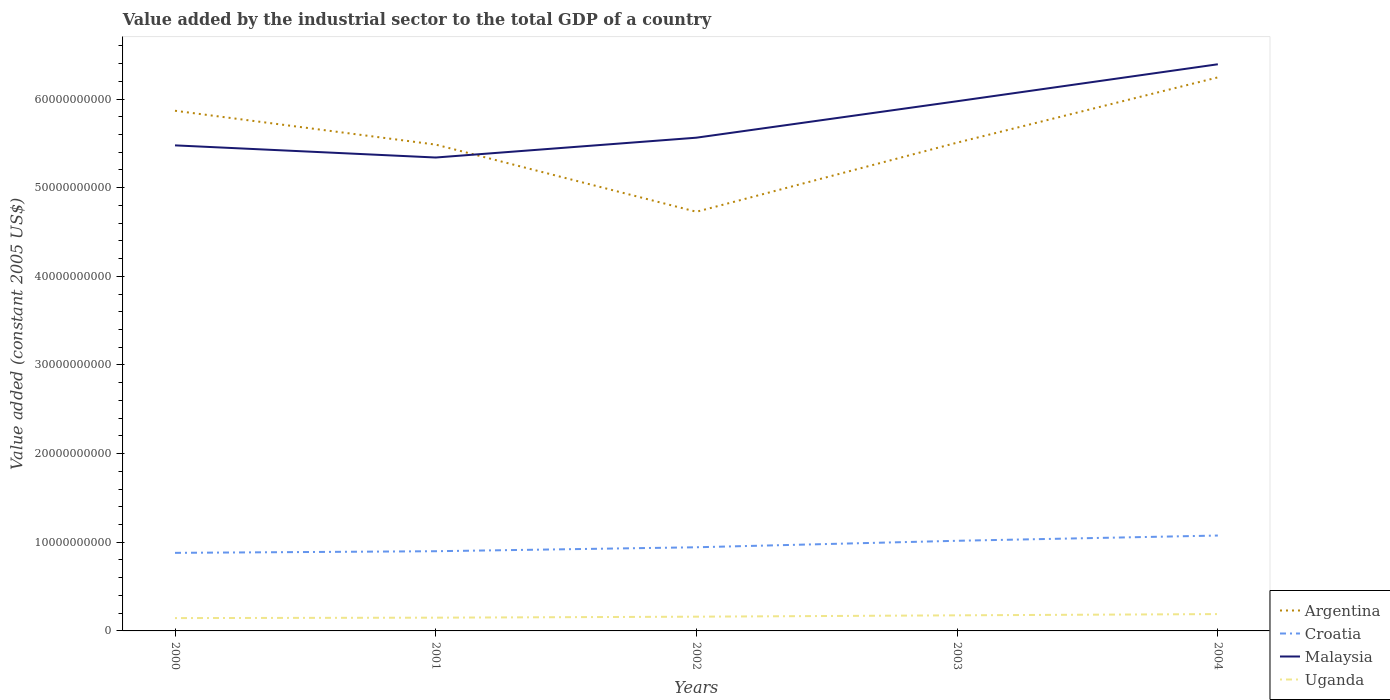Does the line corresponding to Croatia intersect with the line corresponding to Argentina?
Give a very brief answer. No. Is the number of lines equal to the number of legend labels?
Your response must be concise. Yes. Across all years, what is the maximum value added by the industrial sector in Croatia?
Provide a succinct answer. 8.81e+09. In which year was the value added by the industrial sector in Argentina maximum?
Provide a short and direct response. 2002. What is the total value added by the industrial sector in Uganda in the graph?
Offer a very short reply. -1.58e+08. What is the difference between the highest and the second highest value added by the industrial sector in Argentina?
Give a very brief answer. 1.52e+1. What is the difference between two consecutive major ticks on the Y-axis?
Your answer should be compact. 1.00e+1. Are the values on the major ticks of Y-axis written in scientific E-notation?
Your response must be concise. No. Does the graph contain any zero values?
Offer a terse response. No. Does the graph contain grids?
Give a very brief answer. No. Where does the legend appear in the graph?
Make the answer very short. Bottom right. How many legend labels are there?
Offer a very short reply. 4. What is the title of the graph?
Provide a succinct answer. Value added by the industrial sector to the total GDP of a country. Does "Dominican Republic" appear as one of the legend labels in the graph?
Your answer should be very brief. No. What is the label or title of the Y-axis?
Give a very brief answer. Value added (constant 2005 US$). What is the Value added (constant 2005 US$) in Argentina in 2000?
Make the answer very short. 5.87e+1. What is the Value added (constant 2005 US$) in Croatia in 2000?
Give a very brief answer. 8.81e+09. What is the Value added (constant 2005 US$) of Malaysia in 2000?
Your answer should be very brief. 5.48e+1. What is the Value added (constant 2005 US$) of Uganda in 2000?
Your answer should be compact. 1.45e+09. What is the Value added (constant 2005 US$) in Argentina in 2001?
Offer a terse response. 5.49e+1. What is the Value added (constant 2005 US$) of Croatia in 2001?
Provide a short and direct response. 8.99e+09. What is the Value added (constant 2005 US$) of Malaysia in 2001?
Ensure brevity in your answer.  5.34e+1. What is the Value added (constant 2005 US$) of Uganda in 2001?
Keep it short and to the point. 1.50e+09. What is the Value added (constant 2005 US$) in Argentina in 2002?
Your answer should be very brief. 4.73e+1. What is the Value added (constant 2005 US$) in Croatia in 2002?
Give a very brief answer. 9.44e+09. What is the Value added (constant 2005 US$) in Malaysia in 2002?
Offer a very short reply. 5.56e+1. What is the Value added (constant 2005 US$) in Uganda in 2002?
Make the answer very short. 1.61e+09. What is the Value added (constant 2005 US$) of Argentina in 2003?
Give a very brief answer. 5.51e+1. What is the Value added (constant 2005 US$) of Croatia in 2003?
Your answer should be very brief. 1.02e+1. What is the Value added (constant 2005 US$) of Malaysia in 2003?
Offer a terse response. 5.97e+1. What is the Value added (constant 2005 US$) of Uganda in 2003?
Your answer should be very brief. 1.76e+09. What is the Value added (constant 2005 US$) in Argentina in 2004?
Offer a terse response. 6.24e+1. What is the Value added (constant 2005 US$) in Croatia in 2004?
Your answer should be very brief. 1.08e+1. What is the Value added (constant 2005 US$) of Malaysia in 2004?
Offer a terse response. 6.39e+1. What is the Value added (constant 2005 US$) of Uganda in 2004?
Provide a succinct answer. 1.90e+09. Across all years, what is the maximum Value added (constant 2005 US$) of Argentina?
Your answer should be very brief. 6.24e+1. Across all years, what is the maximum Value added (constant 2005 US$) of Croatia?
Keep it short and to the point. 1.08e+1. Across all years, what is the maximum Value added (constant 2005 US$) of Malaysia?
Make the answer very short. 6.39e+1. Across all years, what is the maximum Value added (constant 2005 US$) of Uganda?
Keep it short and to the point. 1.90e+09. Across all years, what is the minimum Value added (constant 2005 US$) in Argentina?
Give a very brief answer. 4.73e+1. Across all years, what is the minimum Value added (constant 2005 US$) in Croatia?
Give a very brief answer. 8.81e+09. Across all years, what is the minimum Value added (constant 2005 US$) of Malaysia?
Your answer should be compact. 5.34e+1. Across all years, what is the minimum Value added (constant 2005 US$) in Uganda?
Ensure brevity in your answer.  1.45e+09. What is the total Value added (constant 2005 US$) of Argentina in the graph?
Give a very brief answer. 2.78e+11. What is the total Value added (constant 2005 US$) in Croatia in the graph?
Your response must be concise. 4.82e+1. What is the total Value added (constant 2005 US$) in Malaysia in the graph?
Provide a short and direct response. 2.87e+11. What is the total Value added (constant 2005 US$) in Uganda in the graph?
Keep it short and to the point. 8.21e+09. What is the difference between the Value added (constant 2005 US$) of Argentina in 2000 and that in 2001?
Make the answer very short. 3.82e+09. What is the difference between the Value added (constant 2005 US$) of Croatia in 2000 and that in 2001?
Offer a very short reply. -1.84e+08. What is the difference between the Value added (constant 2005 US$) of Malaysia in 2000 and that in 2001?
Offer a terse response. 1.37e+09. What is the difference between the Value added (constant 2005 US$) in Uganda in 2000 and that in 2001?
Keep it short and to the point. -4.72e+07. What is the difference between the Value added (constant 2005 US$) of Argentina in 2000 and that in 2002?
Provide a succinct answer. 1.14e+1. What is the difference between the Value added (constant 2005 US$) of Croatia in 2000 and that in 2002?
Your answer should be compact. -6.30e+08. What is the difference between the Value added (constant 2005 US$) in Malaysia in 2000 and that in 2002?
Offer a terse response. -8.67e+08. What is the difference between the Value added (constant 2005 US$) in Uganda in 2000 and that in 2002?
Offer a terse response. -1.58e+08. What is the difference between the Value added (constant 2005 US$) in Argentina in 2000 and that in 2003?
Offer a very short reply. 3.60e+09. What is the difference between the Value added (constant 2005 US$) in Croatia in 2000 and that in 2003?
Your answer should be very brief. -1.36e+09. What is the difference between the Value added (constant 2005 US$) of Malaysia in 2000 and that in 2003?
Your answer should be compact. -4.98e+09. What is the difference between the Value added (constant 2005 US$) in Uganda in 2000 and that in 2003?
Ensure brevity in your answer.  -3.10e+08. What is the difference between the Value added (constant 2005 US$) in Argentina in 2000 and that in 2004?
Your answer should be compact. -3.77e+09. What is the difference between the Value added (constant 2005 US$) in Croatia in 2000 and that in 2004?
Provide a succinct answer. -1.95e+09. What is the difference between the Value added (constant 2005 US$) in Malaysia in 2000 and that in 2004?
Offer a very short reply. -9.15e+09. What is the difference between the Value added (constant 2005 US$) of Uganda in 2000 and that in 2004?
Your response must be concise. -4.51e+08. What is the difference between the Value added (constant 2005 US$) in Argentina in 2001 and that in 2002?
Your response must be concise. 7.58e+09. What is the difference between the Value added (constant 2005 US$) of Croatia in 2001 and that in 2002?
Provide a succinct answer. -4.45e+08. What is the difference between the Value added (constant 2005 US$) in Malaysia in 2001 and that in 2002?
Your response must be concise. -2.24e+09. What is the difference between the Value added (constant 2005 US$) in Uganda in 2001 and that in 2002?
Keep it short and to the point. -1.11e+08. What is the difference between the Value added (constant 2005 US$) in Argentina in 2001 and that in 2003?
Provide a succinct answer. -2.20e+08. What is the difference between the Value added (constant 2005 US$) of Croatia in 2001 and that in 2003?
Keep it short and to the point. -1.18e+09. What is the difference between the Value added (constant 2005 US$) in Malaysia in 2001 and that in 2003?
Your answer should be compact. -6.35e+09. What is the difference between the Value added (constant 2005 US$) in Uganda in 2001 and that in 2003?
Provide a succinct answer. -2.63e+08. What is the difference between the Value added (constant 2005 US$) of Argentina in 2001 and that in 2004?
Your response must be concise. -7.58e+09. What is the difference between the Value added (constant 2005 US$) of Croatia in 2001 and that in 2004?
Your answer should be compact. -1.77e+09. What is the difference between the Value added (constant 2005 US$) of Malaysia in 2001 and that in 2004?
Keep it short and to the point. -1.05e+1. What is the difference between the Value added (constant 2005 US$) of Uganda in 2001 and that in 2004?
Your response must be concise. -4.04e+08. What is the difference between the Value added (constant 2005 US$) in Argentina in 2002 and that in 2003?
Your answer should be very brief. -7.80e+09. What is the difference between the Value added (constant 2005 US$) of Croatia in 2002 and that in 2003?
Your response must be concise. -7.32e+08. What is the difference between the Value added (constant 2005 US$) in Malaysia in 2002 and that in 2003?
Make the answer very short. -4.11e+09. What is the difference between the Value added (constant 2005 US$) in Uganda in 2002 and that in 2003?
Offer a terse response. -1.52e+08. What is the difference between the Value added (constant 2005 US$) in Argentina in 2002 and that in 2004?
Ensure brevity in your answer.  -1.52e+1. What is the difference between the Value added (constant 2005 US$) of Croatia in 2002 and that in 2004?
Offer a very short reply. -1.32e+09. What is the difference between the Value added (constant 2005 US$) of Malaysia in 2002 and that in 2004?
Make the answer very short. -8.28e+09. What is the difference between the Value added (constant 2005 US$) of Uganda in 2002 and that in 2004?
Your answer should be compact. -2.93e+08. What is the difference between the Value added (constant 2005 US$) of Argentina in 2003 and that in 2004?
Your answer should be compact. -7.36e+09. What is the difference between the Value added (constant 2005 US$) in Croatia in 2003 and that in 2004?
Your response must be concise. -5.92e+08. What is the difference between the Value added (constant 2005 US$) of Malaysia in 2003 and that in 2004?
Offer a very short reply. -4.17e+09. What is the difference between the Value added (constant 2005 US$) in Uganda in 2003 and that in 2004?
Offer a very short reply. -1.41e+08. What is the difference between the Value added (constant 2005 US$) in Argentina in 2000 and the Value added (constant 2005 US$) in Croatia in 2001?
Make the answer very short. 4.97e+1. What is the difference between the Value added (constant 2005 US$) in Argentina in 2000 and the Value added (constant 2005 US$) in Malaysia in 2001?
Offer a very short reply. 5.27e+09. What is the difference between the Value added (constant 2005 US$) in Argentina in 2000 and the Value added (constant 2005 US$) in Uganda in 2001?
Your response must be concise. 5.72e+1. What is the difference between the Value added (constant 2005 US$) in Croatia in 2000 and the Value added (constant 2005 US$) in Malaysia in 2001?
Your answer should be compact. -4.46e+1. What is the difference between the Value added (constant 2005 US$) of Croatia in 2000 and the Value added (constant 2005 US$) of Uganda in 2001?
Your response must be concise. 7.31e+09. What is the difference between the Value added (constant 2005 US$) of Malaysia in 2000 and the Value added (constant 2005 US$) of Uganda in 2001?
Make the answer very short. 5.33e+1. What is the difference between the Value added (constant 2005 US$) of Argentina in 2000 and the Value added (constant 2005 US$) of Croatia in 2002?
Ensure brevity in your answer.  4.92e+1. What is the difference between the Value added (constant 2005 US$) in Argentina in 2000 and the Value added (constant 2005 US$) in Malaysia in 2002?
Your answer should be very brief. 3.04e+09. What is the difference between the Value added (constant 2005 US$) in Argentina in 2000 and the Value added (constant 2005 US$) in Uganda in 2002?
Offer a very short reply. 5.71e+1. What is the difference between the Value added (constant 2005 US$) of Croatia in 2000 and the Value added (constant 2005 US$) of Malaysia in 2002?
Give a very brief answer. -4.68e+1. What is the difference between the Value added (constant 2005 US$) of Croatia in 2000 and the Value added (constant 2005 US$) of Uganda in 2002?
Your answer should be very brief. 7.20e+09. What is the difference between the Value added (constant 2005 US$) of Malaysia in 2000 and the Value added (constant 2005 US$) of Uganda in 2002?
Offer a terse response. 5.32e+1. What is the difference between the Value added (constant 2005 US$) of Argentina in 2000 and the Value added (constant 2005 US$) of Croatia in 2003?
Your answer should be very brief. 4.85e+1. What is the difference between the Value added (constant 2005 US$) of Argentina in 2000 and the Value added (constant 2005 US$) of Malaysia in 2003?
Provide a succinct answer. -1.07e+09. What is the difference between the Value added (constant 2005 US$) of Argentina in 2000 and the Value added (constant 2005 US$) of Uganda in 2003?
Provide a short and direct response. 5.69e+1. What is the difference between the Value added (constant 2005 US$) of Croatia in 2000 and the Value added (constant 2005 US$) of Malaysia in 2003?
Ensure brevity in your answer.  -5.09e+1. What is the difference between the Value added (constant 2005 US$) of Croatia in 2000 and the Value added (constant 2005 US$) of Uganda in 2003?
Your answer should be compact. 7.05e+09. What is the difference between the Value added (constant 2005 US$) in Malaysia in 2000 and the Value added (constant 2005 US$) in Uganda in 2003?
Keep it short and to the point. 5.30e+1. What is the difference between the Value added (constant 2005 US$) of Argentina in 2000 and the Value added (constant 2005 US$) of Croatia in 2004?
Provide a succinct answer. 4.79e+1. What is the difference between the Value added (constant 2005 US$) of Argentina in 2000 and the Value added (constant 2005 US$) of Malaysia in 2004?
Ensure brevity in your answer.  -5.24e+09. What is the difference between the Value added (constant 2005 US$) in Argentina in 2000 and the Value added (constant 2005 US$) in Uganda in 2004?
Provide a succinct answer. 5.68e+1. What is the difference between the Value added (constant 2005 US$) of Croatia in 2000 and the Value added (constant 2005 US$) of Malaysia in 2004?
Your response must be concise. -5.51e+1. What is the difference between the Value added (constant 2005 US$) in Croatia in 2000 and the Value added (constant 2005 US$) in Uganda in 2004?
Provide a succinct answer. 6.91e+09. What is the difference between the Value added (constant 2005 US$) of Malaysia in 2000 and the Value added (constant 2005 US$) of Uganda in 2004?
Make the answer very short. 5.29e+1. What is the difference between the Value added (constant 2005 US$) in Argentina in 2001 and the Value added (constant 2005 US$) in Croatia in 2002?
Provide a succinct answer. 4.54e+1. What is the difference between the Value added (constant 2005 US$) in Argentina in 2001 and the Value added (constant 2005 US$) in Malaysia in 2002?
Keep it short and to the point. -7.80e+08. What is the difference between the Value added (constant 2005 US$) in Argentina in 2001 and the Value added (constant 2005 US$) in Uganda in 2002?
Make the answer very short. 5.33e+1. What is the difference between the Value added (constant 2005 US$) in Croatia in 2001 and the Value added (constant 2005 US$) in Malaysia in 2002?
Your answer should be compact. -4.66e+1. What is the difference between the Value added (constant 2005 US$) of Croatia in 2001 and the Value added (constant 2005 US$) of Uganda in 2002?
Offer a very short reply. 7.38e+09. What is the difference between the Value added (constant 2005 US$) in Malaysia in 2001 and the Value added (constant 2005 US$) in Uganda in 2002?
Your response must be concise. 5.18e+1. What is the difference between the Value added (constant 2005 US$) of Argentina in 2001 and the Value added (constant 2005 US$) of Croatia in 2003?
Offer a terse response. 4.47e+1. What is the difference between the Value added (constant 2005 US$) of Argentina in 2001 and the Value added (constant 2005 US$) of Malaysia in 2003?
Your answer should be compact. -4.89e+09. What is the difference between the Value added (constant 2005 US$) of Argentina in 2001 and the Value added (constant 2005 US$) of Uganda in 2003?
Provide a short and direct response. 5.31e+1. What is the difference between the Value added (constant 2005 US$) of Croatia in 2001 and the Value added (constant 2005 US$) of Malaysia in 2003?
Provide a short and direct response. -5.08e+1. What is the difference between the Value added (constant 2005 US$) of Croatia in 2001 and the Value added (constant 2005 US$) of Uganda in 2003?
Offer a very short reply. 7.23e+09. What is the difference between the Value added (constant 2005 US$) in Malaysia in 2001 and the Value added (constant 2005 US$) in Uganda in 2003?
Keep it short and to the point. 5.16e+1. What is the difference between the Value added (constant 2005 US$) of Argentina in 2001 and the Value added (constant 2005 US$) of Croatia in 2004?
Ensure brevity in your answer.  4.41e+1. What is the difference between the Value added (constant 2005 US$) of Argentina in 2001 and the Value added (constant 2005 US$) of Malaysia in 2004?
Offer a very short reply. -9.06e+09. What is the difference between the Value added (constant 2005 US$) of Argentina in 2001 and the Value added (constant 2005 US$) of Uganda in 2004?
Give a very brief answer. 5.30e+1. What is the difference between the Value added (constant 2005 US$) of Croatia in 2001 and the Value added (constant 2005 US$) of Malaysia in 2004?
Your answer should be compact. -5.49e+1. What is the difference between the Value added (constant 2005 US$) in Croatia in 2001 and the Value added (constant 2005 US$) in Uganda in 2004?
Offer a terse response. 7.09e+09. What is the difference between the Value added (constant 2005 US$) of Malaysia in 2001 and the Value added (constant 2005 US$) of Uganda in 2004?
Your answer should be compact. 5.15e+1. What is the difference between the Value added (constant 2005 US$) of Argentina in 2002 and the Value added (constant 2005 US$) of Croatia in 2003?
Your answer should be very brief. 3.71e+1. What is the difference between the Value added (constant 2005 US$) of Argentina in 2002 and the Value added (constant 2005 US$) of Malaysia in 2003?
Provide a succinct answer. -1.25e+1. What is the difference between the Value added (constant 2005 US$) of Argentina in 2002 and the Value added (constant 2005 US$) of Uganda in 2003?
Offer a very short reply. 4.55e+1. What is the difference between the Value added (constant 2005 US$) in Croatia in 2002 and the Value added (constant 2005 US$) in Malaysia in 2003?
Ensure brevity in your answer.  -5.03e+1. What is the difference between the Value added (constant 2005 US$) of Croatia in 2002 and the Value added (constant 2005 US$) of Uganda in 2003?
Provide a short and direct response. 7.68e+09. What is the difference between the Value added (constant 2005 US$) in Malaysia in 2002 and the Value added (constant 2005 US$) in Uganda in 2003?
Ensure brevity in your answer.  5.39e+1. What is the difference between the Value added (constant 2005 US$) of Argentina in 2002 and the Value added (constant 2005 US$) of Croatia in 2004?
Your answer should be very brief. 3.65e+1. What is the difference between the Value added (constant 2005 US$) of Argentina in 2002 and the Value added (constant 2005 US$) of Malaysia in 2004?
Your answer should be compact. -1.66e+1. What is the difference between the Value added (constant 2005 US$) in Argentina in 2002 and the Value added (constant 2005 US$) in Uganda in 2004?
Give a very brief answer. 4.54e+1. What is the difference between the Value added (constant 2005 US$) in Croatia in 2002 and the Value added (constant 2005 US$) in Malaysia in 2004?
Make the answer very short. -5.45e+1. What is the difference between the Value added (constant 2005 US$) in Croatia in 2002 and the Value added (constant 2005 US$) in Uganda in 2004?
Make the answer very short. 7.54e+09. What is the difference between the Value added (constant 2005 US$) of Malaysia in 2002 and the Value added (constant 2005 US$) of Uganda in 2004?
Provide a succinct answer. 5.37e+1. What is the difference between the Value added (constant 2005 US$) in Argentina in 2003 and the Value added (constant 2005 US$) in Croatia in 2004?
Your answer should be very brief. 4.43e+1. What is the difference between the Value added (constant 2005 US$) in Argentina in 2003 and the Value added (constant 2005 US$) in Malaysia in 2004?
Your response must be concise. -8.84e+09. What is the difference between the Value added (constant 2005 US$) of Argentina in 2003 and the Value added (constant 2005 US$) of Uganda in 2004?
Keep it short and to the point. 5.32e+1. What is the difference between the Value added (constant 2005 US$) of Croatia in 2003 and the Value added (constant 2005 US$) of Malaysia in 2004?
Offer a terse response. -5.38e+1. What is the difference between the Value added (constant 2005 US$) in Croatia in 2003 and the Value added (constant 2005 US$) in Uganda in 2004?
Your answer should be very brief. 8.27e+09. What is the difference between the Value added (constant 2005 US$) in Malaysia in 2003 and the Value added (constant 2005 US$) in Uganda in 2004?
Keep it short and to the point. 5.78e+1. What is the average Value added (constant 2005 US$) of Argentina per year?
Provide a succinct answer. 5.57e+1. What is the average Value added (constant 2005 US$) in Croatia per year?
Give a very brief answer. 9.63e+09. What is the average Value added (constant 2005 US$) of Malaysia per year?
Your answer should be very brief. 5.75e+1. What is the average Value added (constant 2005 US$) of Uganda per year?
Offer a terse response. 1.64e+09. In the year 2000, what is the difference between the Value added (constant 2005 US$) in Argentina and Value added (constant 2005 US$) in Croatia?
Keep it short and to the point. 4.99e+1. In the year 2000, what is the difference between the Value added (constant 2005 US$) in Argentina and Value added (constant 2005 US$) in Malaysia?
Offer a very short reply. 3.90e+09. In the year 2000, what is the difference between the Value added (constant 2005 US$) in Argentina and Value added (constant 2005 US$) in Uganda?
Provide a succinct answer. 5.72e+1. In the year 2000, what is the difference between the Value added (constant 2005 US$) in Croatia and Value added (constant 2005 US$) in Malaysia?
Keep it short and to the point. -4.60e+1. In the year 2000, what is the difference between the Value added (constant 2005 US$) in Croatia and Value added (constant 2005 US$) in Uganda?
Give a very brief answer. 7.36e+09. In the year 2000, what is the difference between the Value added (constant 2005 US$) of Malaysia and Value added (constant 2005 US$) of Uganda?
Provide a succinct answer. 5.33e+1. In the year 2001, what is the difference between the Value added (constant 2005 US$) of Argentina and Value added (constant 2005 US$) of Croatia?
Make the answer very short. 4.59e+1. In the year 2001, what is the difference between the Value added (constant 2005 US$) of Argentina and Value added (constant 2005 US$) of Malaysia?
Make the answer very short. 1.46e+09. In the year 2001, what is the difference between the Value added (constant 2005 US$) in Argentina and Value added (constant 2005 US$) in Uganda?
Offer a very short reply. 5.34e+1. In the year 2001, what is the difference between the Value added (constant 2005 US$) in Croatia and Value added (constant 2005 US$) in Malaysia?
Your answer should be compact. -4.44e+1. In the year 2001, what is the difference between the Value added (constant 2005 US$) in Croatia and Value added (constant 2005 US$) in Uganda?
Provide a short and direct response. 7.49e+09. In the year 2001, what is the difference between the Value added (constant 2005 US$) of Malaysia and Value added (constant 2005 US$) of Uganda?
Keep it short and to the point. 5.19e+1. In the year 2002, what is the difference between the Value added (constant 2005 US$) of Argentina and Value added (constant 2005 US$) of Croatia?
Offer a terse response. 3.78e+1. In the year 2002, what is the difference between the Value added (constant 2005 US$) in Argentina and Value added (constant 2005 US$) in Malaysia?
Offer a very short reply. -8.36e+09. In the year 2002, what is the difference between the Value added (constant 2005 US$) in Argentina and Value added (constant 2005 US$) in Uganda?
Provide a succinct answer. 4.57e+1. In the year 2002, what is the difference between the Value added (constant 2005 US$) in Croatia and Value added (constant 2005 US$) in Malaysia?
Provide a short and direct response. -4.62e+1. In the year 2002, what is the difference between the Value added (constant 2005 US$) in Croatia and Value added (constant 2005 US$) in Uganda?
Provide a short and direct response. 7.83e+09. In the year 2002, what is the difference between the Value added (constant 2005 US$) of Malaysia and Value added (constant 2005 US$) of Uganda?
Give a very brief answer. 5.40e+1. In the year 2003, what is the difference between the Value added (constant 2005 US$) of Argentina and Value added (constant 2005 US$) of Croatia?
Provide a succinct answer. 4.49e+1. In the year 2003, what is the difference between the Value added (constant 2005 US$) in Argentina and Value added (constant 2005 US$) in Malaysia?
Give a very brief answer. -4.67e+09. In the year 2003, what is the difference between the Value added (constant 2005 US$) of Argentina and Value added (constant 2005 US$) of Uganda?
Your answer should be compact. 5.33e+1. In the year 2003, what is the difference between the Value added (constant 2005 US$) in Croatia and Value added (constant 2005 US$) in Malaysia?
Ensure brevity in your answer.  -4.96e+1. In the year 2003, what is the difference between the Value added (constant 2005 US$) in Croatia and Value added (constant 2005 US$) in Uganda?
Offer a terse response. 8.41e+09. In the year 2003, what is the difference between the Value added (constant 2005 US$) of Malaysia and Value added (constant 2005 US$) of Uganda?
Your answer should be very brief. 5.80e+1. In the year 2004, what is the difference between the Value added (constant 2005 US$) in Argentina and Value added (constant 2005 US$) in Croatia?
Provide a succinct answer. 5.17e+1. In the year 2004, what is the difference between the Value added (constant 2005 US$) of Argentina and Value added (constant 2005 US$) of Malaysia?
Offer a very short reply. -1.48e+09. In the year 2004, what is the difference between the Value added (constant 2005 US$) of Argentina and Value added (constant 2005 US$) of Uganda?
Provide a short and direct response. 6.05e+1. In the year 2004, what is the difference between the Value added (constant 2005 US$) of Croatia and Value added (constant 2005 US$) of Malaysia?
Keep it short and to the point. -5.32e+1. In the year 2004, what is the difference between the Value added (constant 2005 US$) in Croatia and Value added (constant 2005 US$) in Uganda?
Your answer should be compact. 8.86e+09. In the year 2004, what is the difference between the Value added (constant 2005 US$) in Malaysia and Value added (constant 2005 US$) in Uganda?
Ensure brevity in your answer.  6.20e+1. What is the ratio of the Value added (constant 2005 US$) of Argentina in 2000 to that in 2001?
Your answer should be very brief. 1.07. What is the ratio of the Value added (constant 2005 US$) in Croatia in 2000 to that in 2001?
Provide a succinct answer. 0.98. What is the ratio of the Value added (constant 2005 US$) in Malaysia in 2000 to that in 2001?
Provide a short and direct response. 1.03. What is the ratio of the Value added (constant 2005 US$) in Uganda in 2000 to that in 2001?
Offer a terse response. 0.97. What is the ratio of the Value added (constant 2005 US$) of Argentina in 2000 to that in 2002?
Provide a succinct answer. 1.24. What is the ratio of the Value added (constant 2005 US$) of Malaysia in 2000 to that in 2002?
Provide a succinct answer. 0.98. What is the ratio of the Value added (constant 2005 US$) of Uganda in 2000 to that in 2002?
Make the answer very short. 0.9. What is the ratio of the Value added (constant 2005 US$) in Argentina in 2000 to that in 2003?
Provide a short and direct response. 1.07. What is the ratio of the Value added (constant 2005 US$) of Croatia in 2000 to that in 2003?
Make the answer very short. 0.87. What is the ratio of the Value added (constant 2005 US$) in Malaysia in 2000 to that in 2003?
Provide a succinct answer. 0.92. What is the ratio of the Value added (constant 2005 US$) of Uganda in 2000 to that in 2003?
Your response must be concise. 0.82. What is the ratio of the Value added (constant 2005 US$) in Argentina in 2000 to that in 2004?
Give a very brief answer. 0.94. What is the ratio of the Value added (constant 2005 US$) in Croatia in 2000 to that in 2004?
Your answer should be compact. 0.82. What is the ratio of the Value added (constant 2005 US$) in Malaysia in 2000 to that in 2004?
Provide a succinct answer. 0.86. What is the ratio of the Value added (constant 2005 US$) in Uganda in 2000 to that in 2004?
Make the answer very short. 0.76. What is the ratio of the Value added (constant 2005 US$) in Argentina in 2001 to that in 2002?
Your answer should be compact. 1.16. What is the ratio of the Value added (constant 2005 US$) of Croatia in 2001 to that in 2002?
Your answer should be very brief. 0.95. What is the ratio of the Value added (constant 2005 US$) in Malaysia in 2001 to that in 2002?
Provide a short and direct response. 0.96. What is the ratio of the Value added (constant 2005 US$) in Argentina in 2001 to that in 2003?
Keep it short and to the point. 1. What is the ratio of the Value added (constant 2005 US$) of Croatia in 2001 to that in 2003?
Your response must be concise. 0.88. What is the ratio of the Value added (constant 2005 US$) in Malaysia in 2001 to that in 2003?
Make the answer very short. 0.89. What is the ratio of the Value added (constant 2005 US$) of Uganda in 2001 to that in 2003?
Your answer should be very brief. 0.85. What is the ratio of the Value added (constant 2005 US$) of Argentina in 2001 to that in 2004?
Your response must be concise. 0.88. What is the ratio of the Value added (constant 2005 US$) in Croatia in 2001 to that in 2004?
Your answer should be very brief. 0.84. What is the ratio of the Value added (constant 2005 US$) of Malaysia in 2001 to that in 2004?
Ensure brevity in your answer.  0.84. What is the ratio of the Value added (constant 2005 US$) of Uganda in 2001 to that in 2004?
Offer a very short reply. 0.79. What is the ratio of the Value added (constant 2005 US$) in Argentina in 2002 to that in 2003?
Your response must be concise. 0.86. What is the ratio of the Value added (constant 2005 US$) in Croatia in 2002 to that in 2003?
Provide a short and direct response. 0.93. What is the ratio of the Value added (constant 2005 US$) of Malaysia in 2002 to that in 2003?
Provide a succinct answer. 0.93. What is the ratio of the Value added (constant 2005 US$) in Uganda in 2002 to that in 2003?
Your answer should be very brief. 0.91. What is the ratio of the Value added (constant 2005 US$) of Argentina in 2002 to that in 2004?
Your answer should be compact. 0.76. What is the ratio of the Value added (constant 2005 US$) of Croatia in 2002 to that in 2004?
Keep it short and to the point. 0.88. What is the ratio of the Value added (constant 2005 US$) of Malaysia in 2002 to that in 2004?
Offer a very short reply. 0.87. What is the ratio of the Value added (constant 2005 US$) in Uganda in 2002 to that in 2004?
Make the answer very short. 0.85. What is the ratio of the Value added (constant 2005 US$) of Argentina in 2003 to that in 2004?
Provide a succinct answer. 0.88. What is the ratio of the Value added (constant 2005 US$) of Croatia in 2003 to that in 2004?
Your answer should be very brief. 0.94. What is the ratio of the Value added (constant 2005 US$) of Malaysia in 2003 to that in 2004?
Make the answer very short. 0.93. What is the ratio of the Value added (constant 2005 US$) in Uganda in 2003 to that in 2004?
Offer a very short reply. 0.93. What is the difference between the highest and the second highest Value added (constant 2005 US$) of Argentina?
Provide a succinct answer. 3.77e+09. What is the difference between the highest and the second highest Value added (constant 2005 US$) of Croatia?
Your response must be concise. 5.92e+08. What is the difference between the highest and the second highest Value added (constant 2005 US$) of Malaysia?
Offer a terse response. 4.17e+09. What is the difference between the highest and the second highest Value added (constant 2005 US$) in Uganda?
Give a very brief answer. 1.41e+08. What is the difference between the highest and the lowest Value added (constant 2005 US$) in Argentina?
Keep it short and to the point. 1.52e+1. What is the difference between the highest and the lowest Value added (constant 2005 US$) in Croatia?
Ensure brevity in your answer.  1.95e+09. What is the difference between the highest and the lowest Value added (constant 2005 US$) of Malaysia?
Your response must be concise. 1.05e+1. What is the difference between the highest and the lowest Value added (constant 2005 US$) of Uganda?
Offer a terse response. 4.51e+08. 